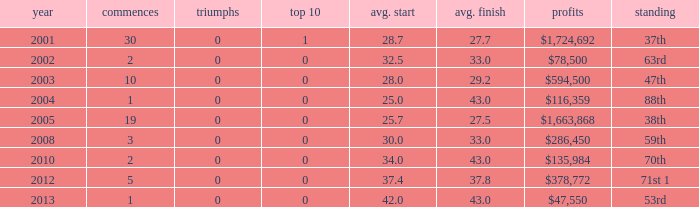How many wins for average start less than 25? 0.0. 